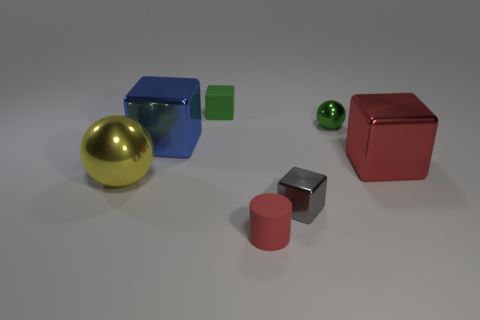What can you infer about the texture of the objects, particularly the red one? The red object has a glossy finish that reflects light brightly, indicating a smooth texture. Its crisp edges and the clean reflection suggest it might feel slick to the touch.  Is there any pattern in the positioning of the objects? The objects appear to be deliberately placed to demonstrate contrast in color, shape, and size. There doesn't seem to be a specific pattern, but the arrangement allows each object to stand out individually. 